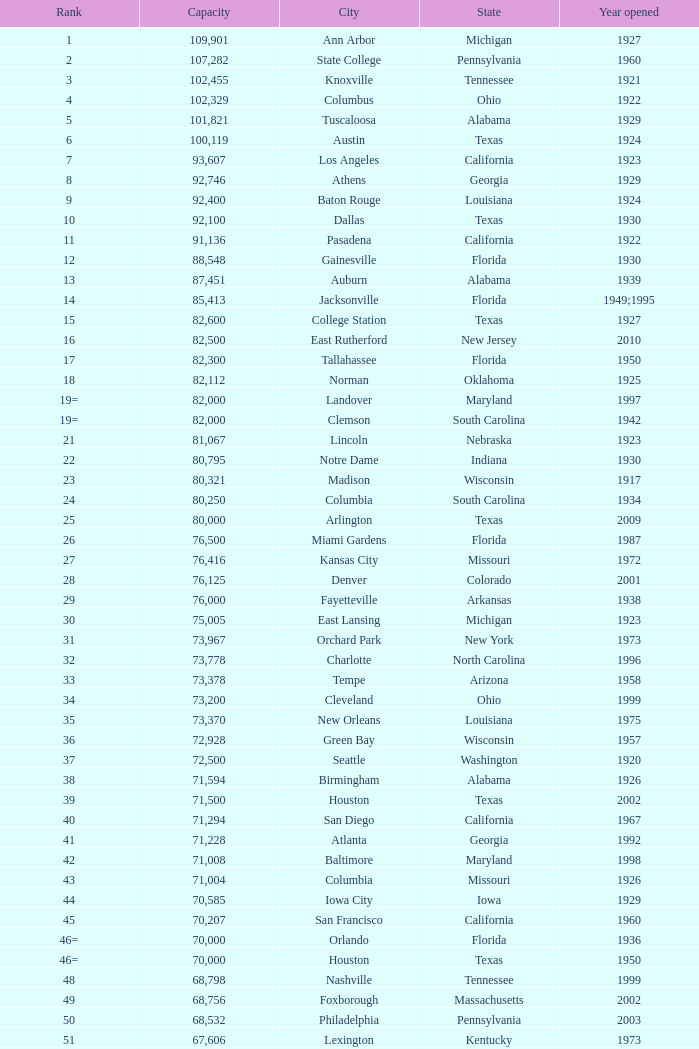What is the rank for the year opened in 1959 in Pennsylvania? 134=. 